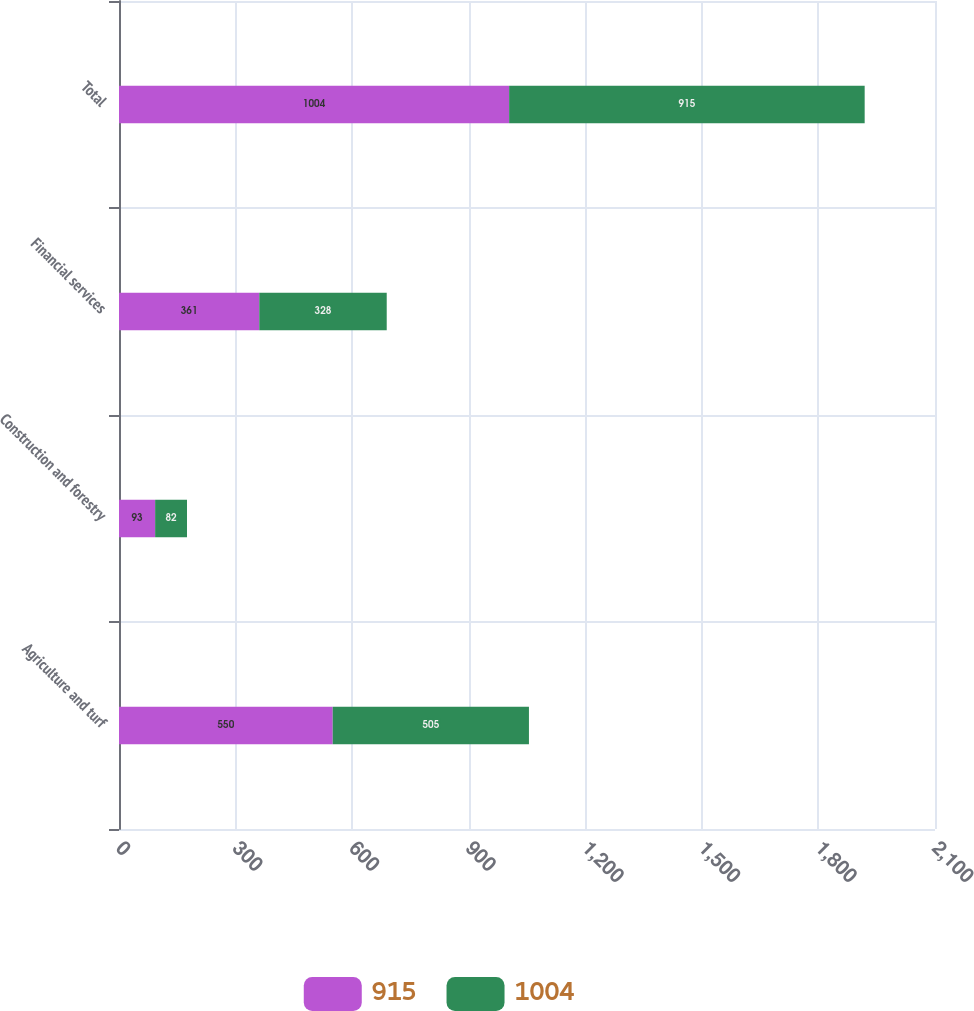<chart> <loc_0><loc_0><loc_500><loc_500><stacked_bar_chart><ecel><fcel>Agriculture and turf<fcel>Construction and forestry<fcel>Financial services<fcel>Total<nl><fcel>915<fcel>550<fcel>93<fcel>361<fcel>1004<nl><fcel>1004<fcel>505<fcel>82<fcel>328<fcel>915<nl></chart> 